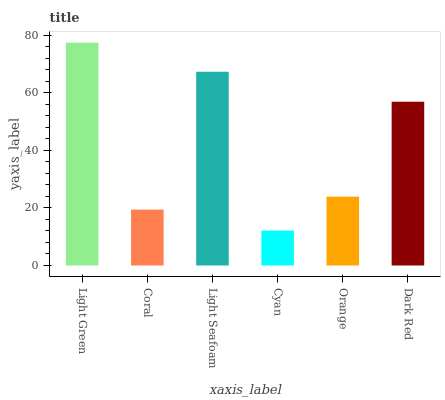Is Cyan the minimum?
Answer yes or no. Yes. Is Light Green the maximum?
Answer yes or no. Yes. Is Coral the minimum?
Answer yes or no. No. Is Coral the maximum?
Answer yes or no. No. Is Light Green greater than Coral?
Answer yes or no. Yes. Is Coral less than Light Green?
Answer yes or no. Yes. Is Coral greater than Light Green?
Answer yes or no. No. Is Light Green less than Coral?
Answer yes or no. No. Is Dark Red the high median?
Answer yes or no. Yes. Is Orange the low median?
Answer yes or no. Yes. Is Cyan the high median?
Answer yes or no. No. Is Light Green the low median?
Answer yes or no. No. 